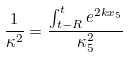Convert formula to latex. <formula><loc_0><loc_0><loc_500><loc_500>\frac { 1 } { \kappa ^ { 2 } } = \frac { \int _ { t - R } ^ { t } e ^ { 2 k x _ { 5 } } } { \kappa _ { 5 } ^ { 2 } }</formula> 